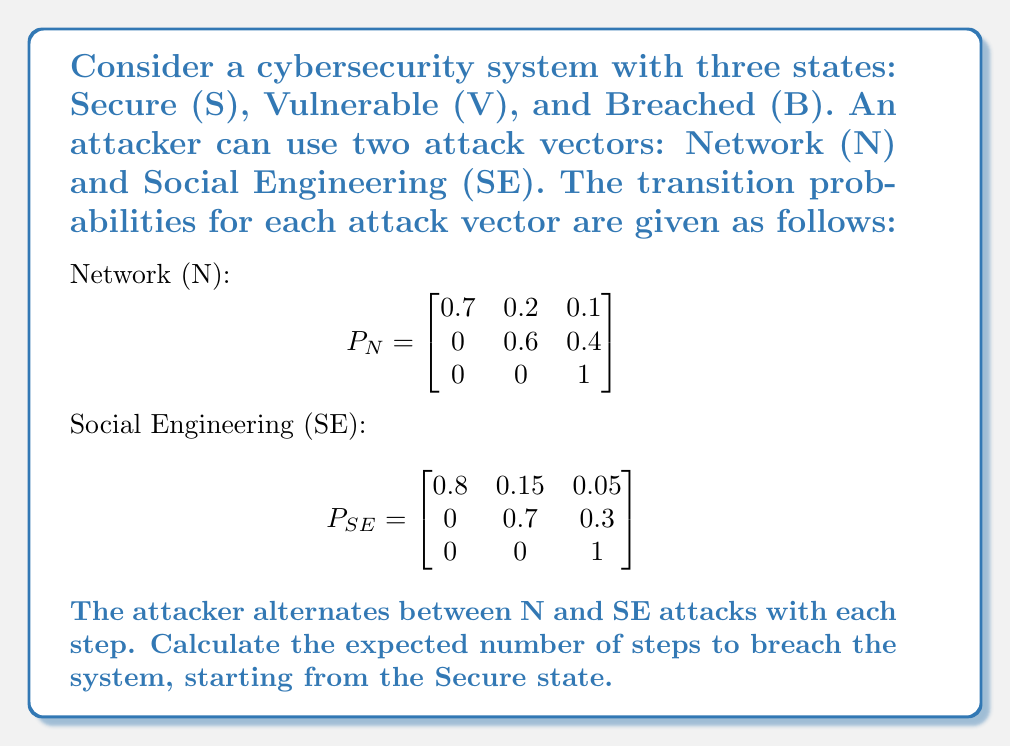Provide a solution to this math problem. To solve this problem, we need to use the concept of absorbing Markov chains and calculate the expected time to absorption. The steps are as follows:

1) First, we need to combine the two transition matrices into a single matrix that represents the average transition probabilities over two steps (N followed by SE):

   $$P = P_N \times P_{SE} = \begin{bmatrix}
   0.7 & 0.2 & 0.1 \\
   0 & 0.6 & 0.4 \\
   0 & 0 & 1
   \end{bmatrix} \times \begin{bmatrix}
   0.8 & 0.15 & 0.05 \\
   0 & 0.7 & 0.3 \\
   0 & 0 & 1
   \end{bmatrix}$$

   $$P = \begin{bmatrix}
   0.56 & 0.245 & 0.195 \\
   0 & 0.42 & 0.58 \\
   0 & 0 & 1
   \end{bmatrix}$$

2) Now, we have an absorbing Markov chain with one absorbing state (B) and two transient states (S and V). We can rewrite the matrix in the canonical form:

   $$P = \begin{bmatrix}
   Q & R \\
   0 & I
   \end{bmatrix} = \begin{bmatrix}
   0.56 & 0.245 & 0.195 \\
   0 & 0.42 & 0.58 \\
   0 & 0 & 1
   \end{bmatrix}$$

   Where $Q = \begin{bmatrix}
   0.56 & 0.245 \\
   0 & 0.42
   \end{bmatrix}$

3) To find the expected number of steps to absorption, we calculate the fundamental matrix $N = (I-Q)^{-1}$:

   $$N = (I-Q)^{-1} = \begin{bmatrix}
   1-0.56 & -0.245 \\
   0 & 1-0.42
   \end{bmatrix}^{-1} = \begin{bmatrix}
   0.44 & -0.245 \\
   0 & 0.58
   \end{bmatrix}^{-1}$$

   $$N = \begin{bmatrix}
   2.2727 & 0.9596 \\
   0 & 1.7241
   \end{bmatrix}$$

4) The expected number of steps to absorption, starting from the Secure state, is the sum of the first row of $N$:

   $E[T] = 2.2727 + 0.9596 = 3.2323$

5) Since each step in our combined matrix represents two actual attacks (N followed by SE), we need to multiply this result by 2:

   $E[T_{actual}] = 3.2323 \times 2 = 6.4646$

Therefore, the expected number of individual attacks (alternating between N and SE) to breach the system, starting from the Secure state, is approximately 6.4646.
Answer: 6.4646 attacks 